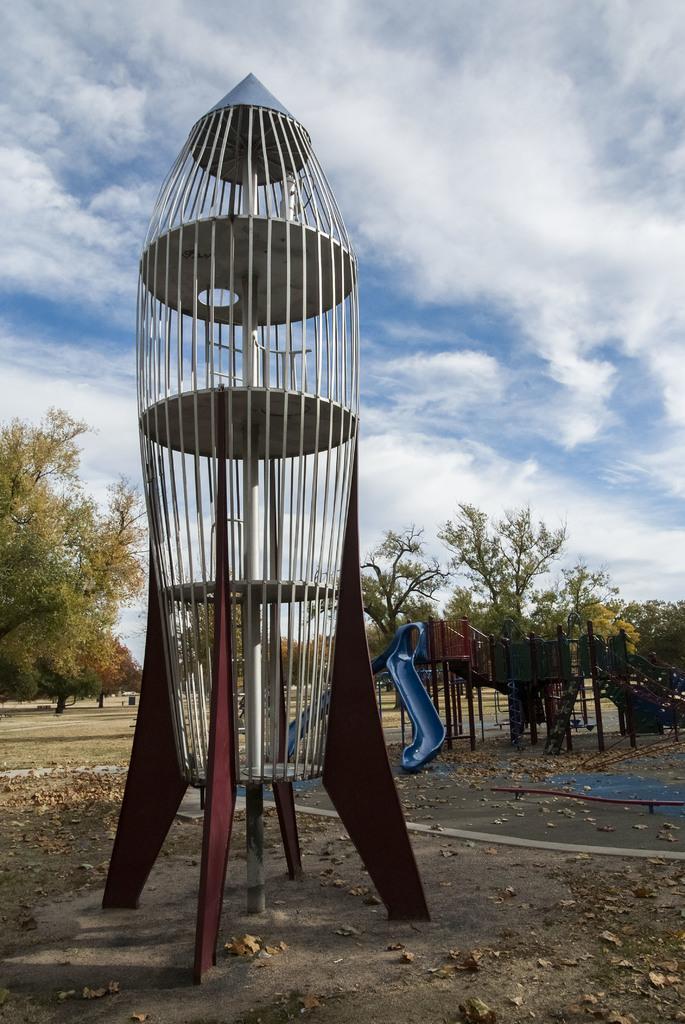Can you describe this image briefly? In this image there are few playing objects are on the land having few trees. Top of the image there is sky with some clouds. 